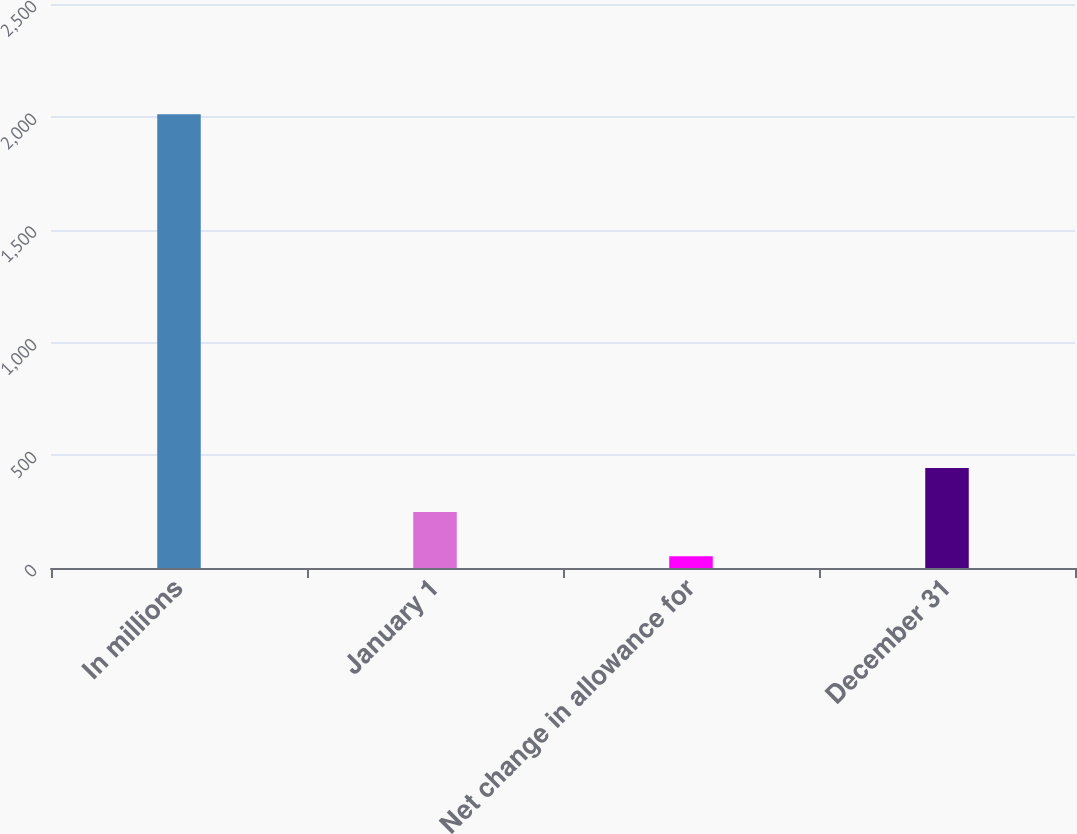<chart> <loc_0><loc_0><loc_500><loc_500><bar_chart><fcel>In millions<fcel>January 1<fcel>Net change in allowance for<fcel>December 31<nl><fcel>2011<fcel>247.9<fcel>52<fcel>443.8<nl></chart> 